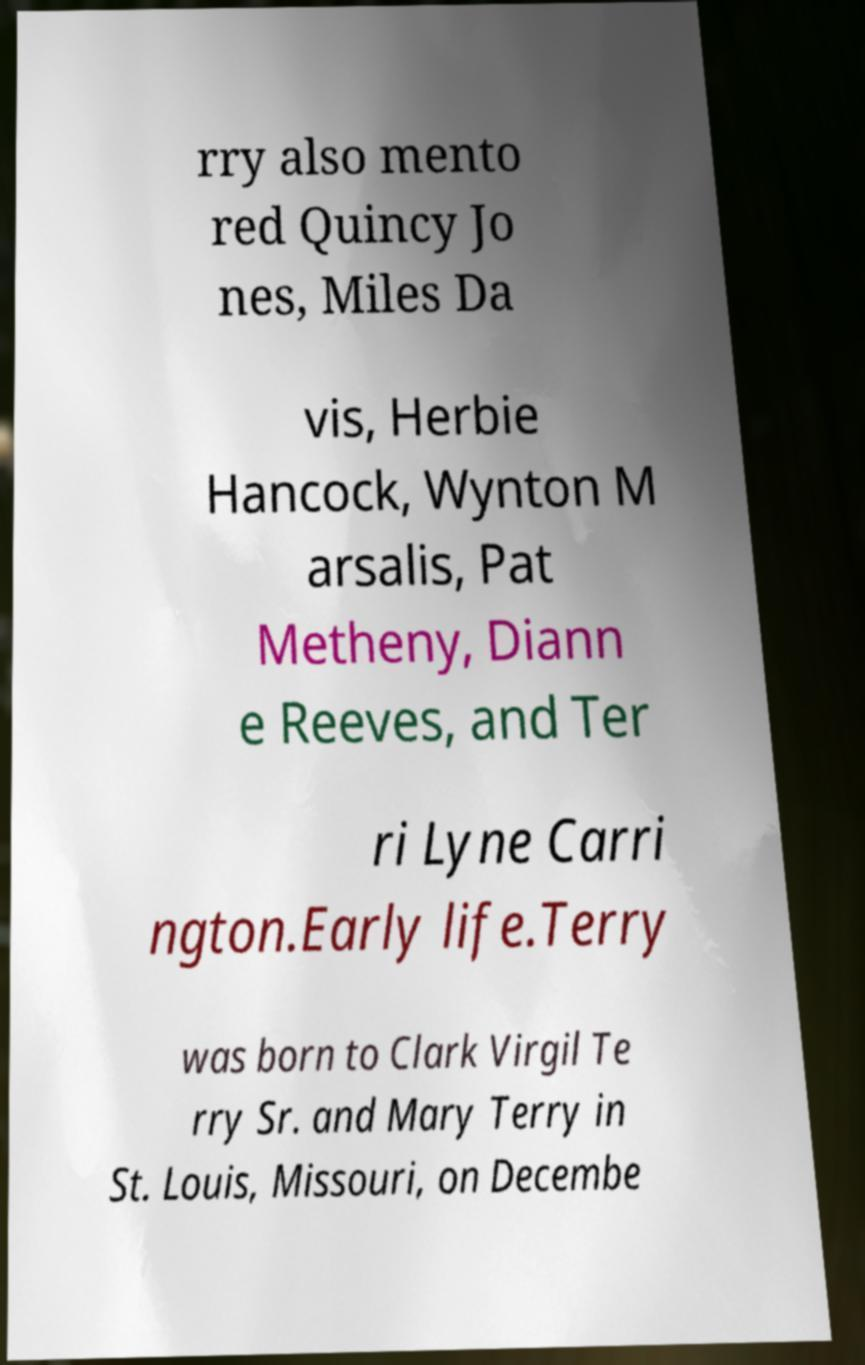Can you read and provide the text displayed in the image?This photo seems to have some interesting text. Can you extract and type it out for me? rry also mento red Quincy Jo nes, Miles Da vis, Herbie Hancock, Wynton M arsalis, Pat Metheny, Diann e Reeves, and Ter ri Lyne Carri ngton.Early life.Terry was born to Clark Virgil Te rry Sr. and Mary Terry in St. Louis, Missouri, on Decembe 